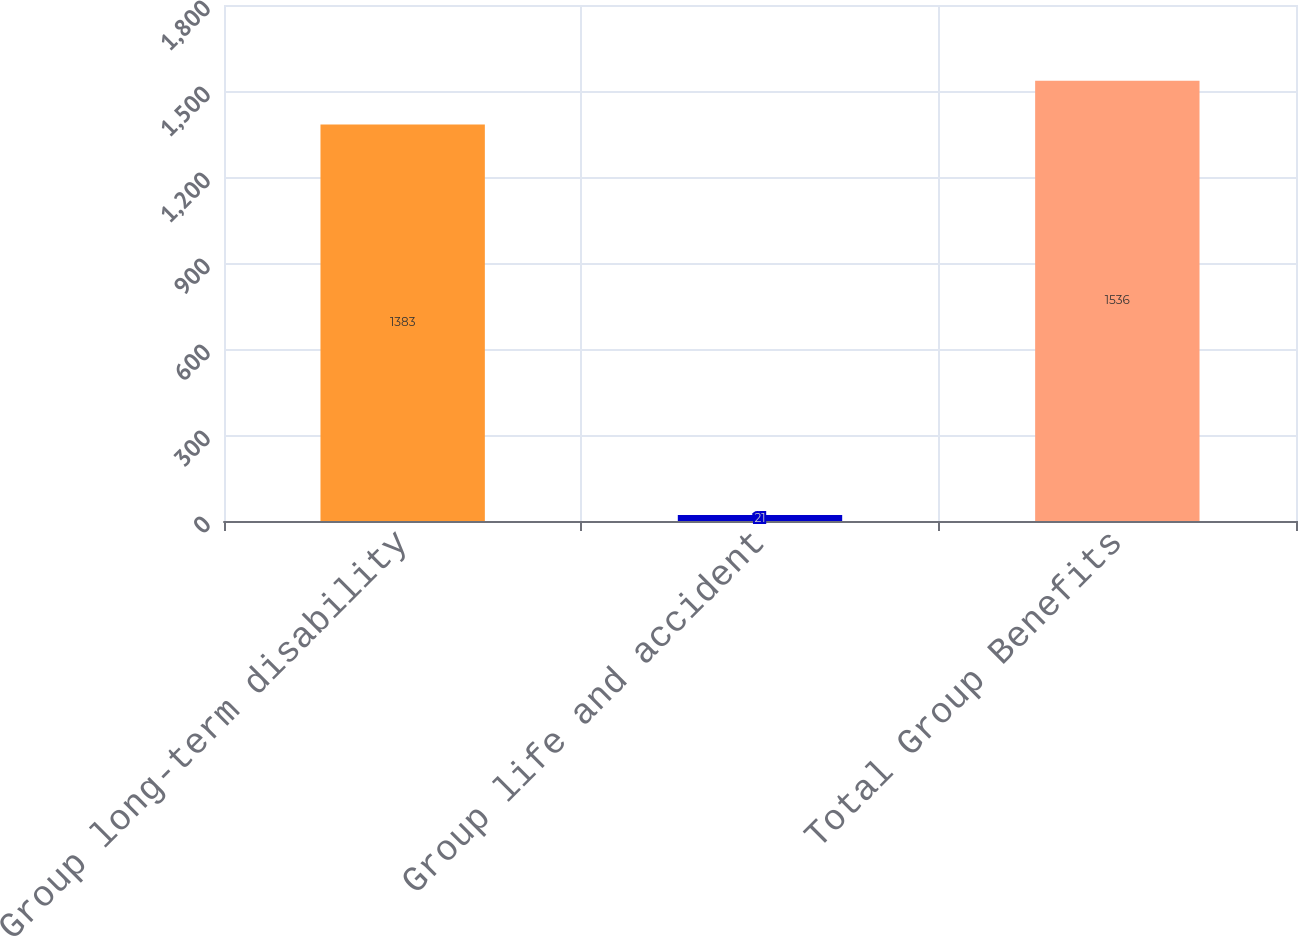<chart> <loc_0><loc_0><loc_500><loc_500><bar_chart><fcel>Group long-term disability<fcel>Group life and accident<fcel>Total Group Benefits<nl><fcel>1383<fcel>21<fcel>1536<nl></chart> 